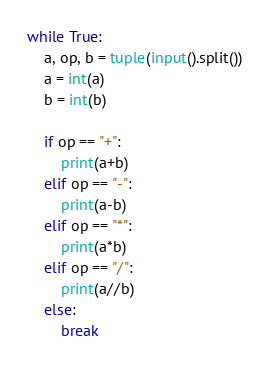Convert code to text. <code><loc_0><loc_0><loc_500><loc_500><_Python_>while True:
    a, op, b = tuple(input().split())
    a = int(a)
    b = int(b)

    if op == "+":
        print(a+b)
    elif op == "-":
        print(a-b)
    elif op == "*":
        print(a*b)
    elif op == "/":
        print(a//b)
    else:
        break
</code> 